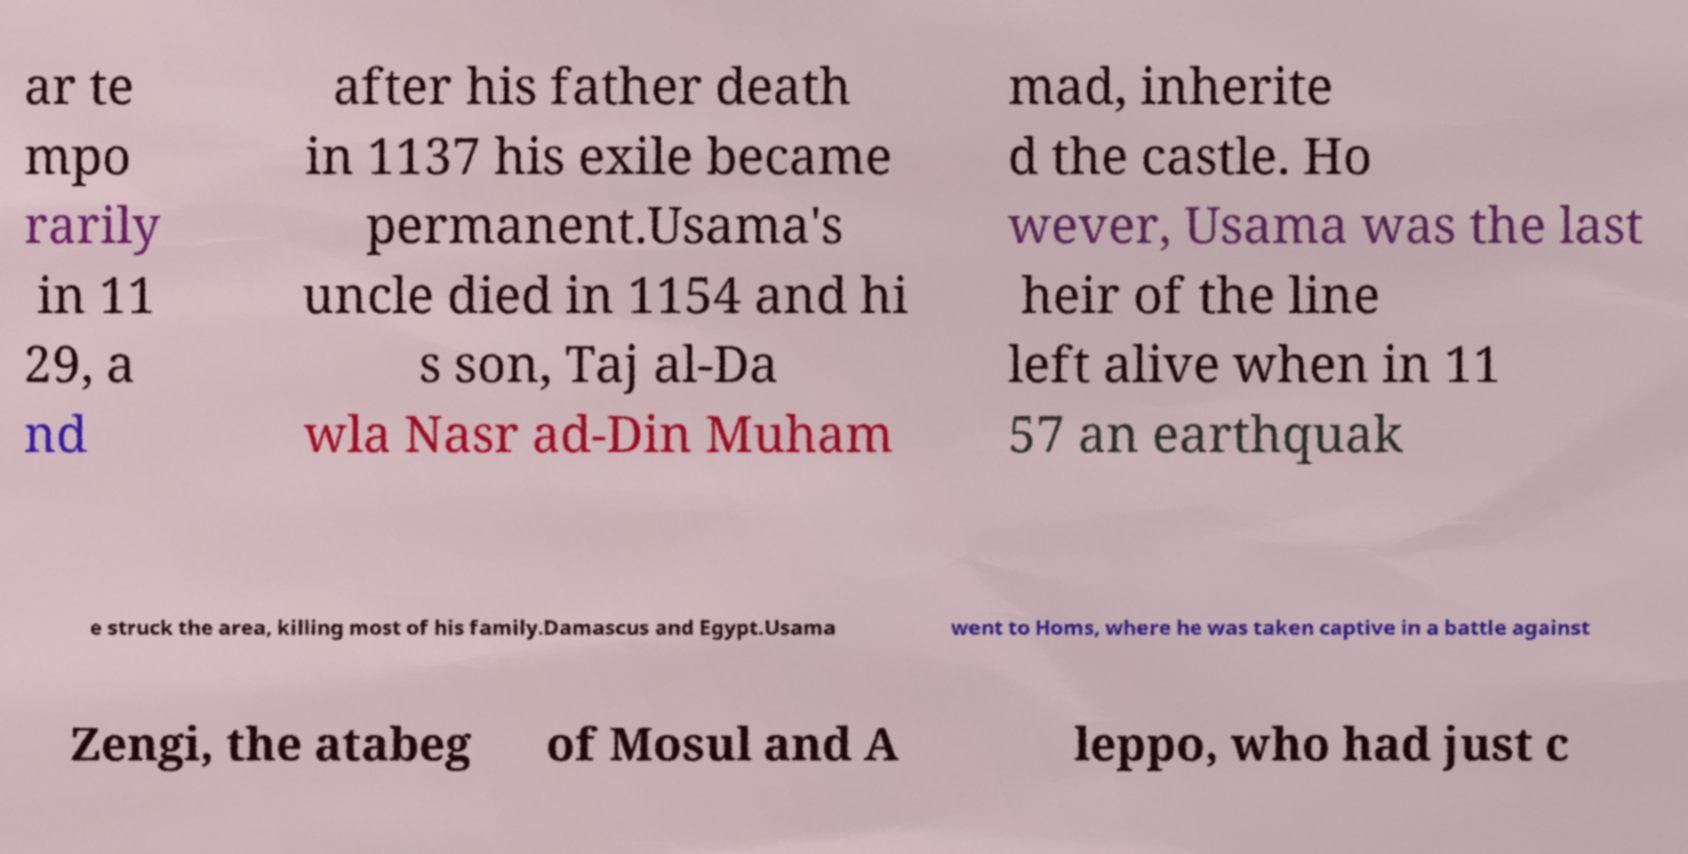What messages or text are displayed in this image? I need them in a readable, typed format. ar te mpo rarily in 11 29, a nd after his father death in 1137 his exile became permanent.Usama's uncle died in 1154 and hi s son, Taj al-Da wla Nasr ad-Din Muham mad, inherite d the castle. Ho wever, Usama was the last heir of the line left alive when in 11 57 an earthquak e struck the area, killing most of his family.Damascus and Egypt.Usama went to Homs, where he was taken captive in a battle against Zengi, the atabeg of Mosul and A leppo, who had just c 